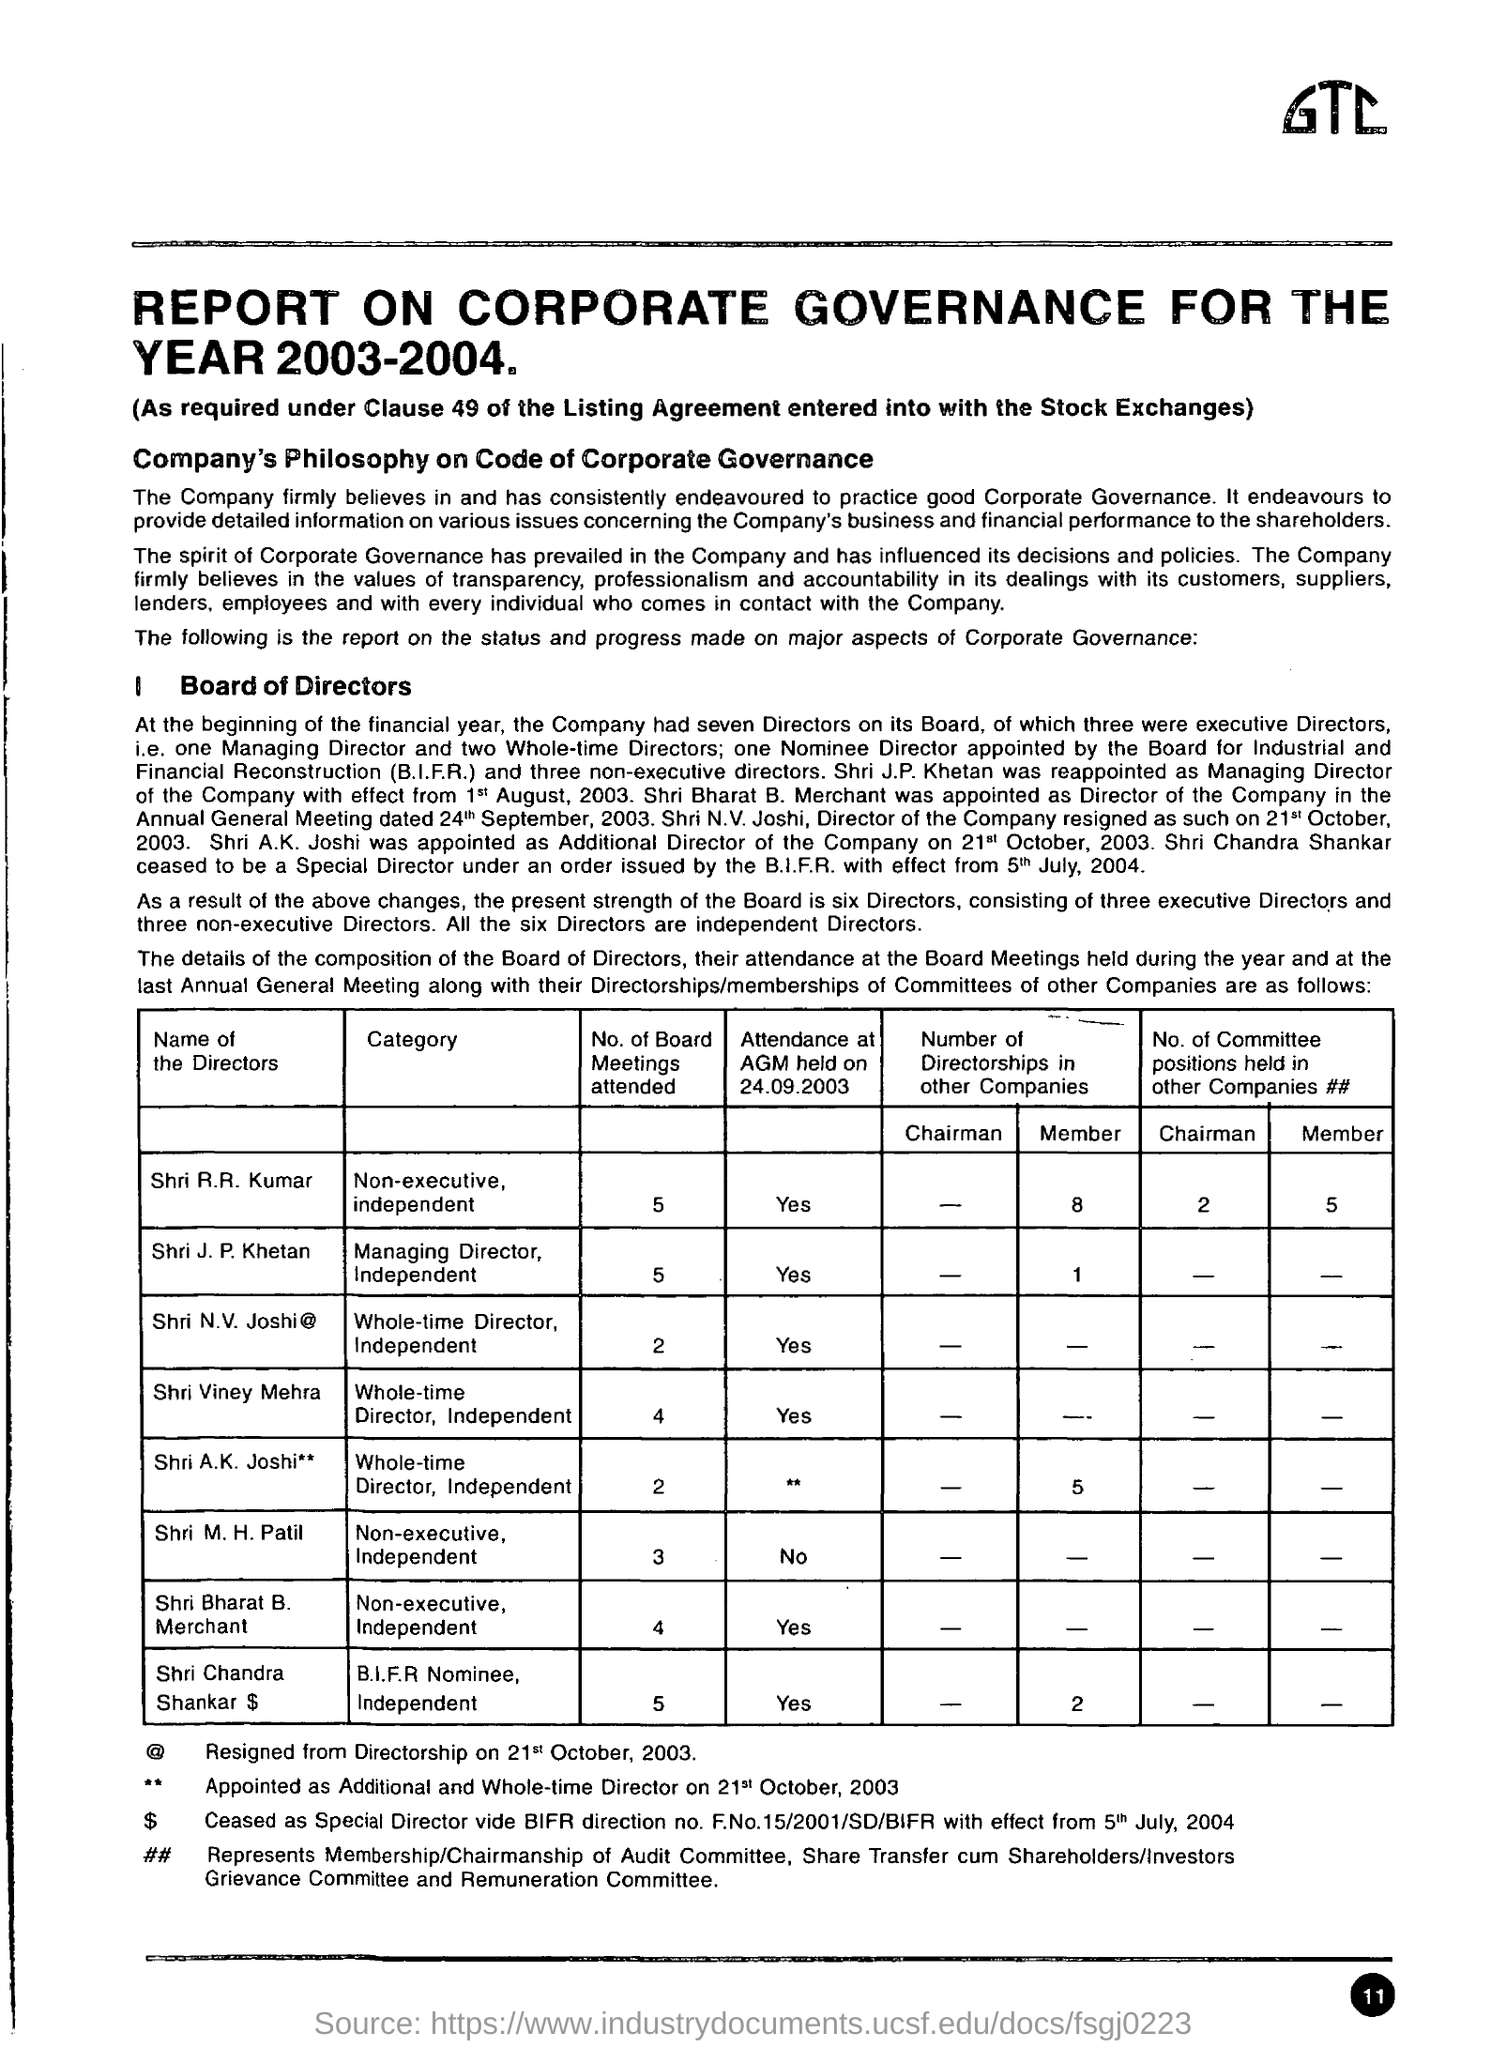At the beginning of the financial year, how many directors did the company have? According to the 'REPORT ON CORPORATE GOVERNANCE FOR THE YEAR 2003-2004', the company had seven directors at the start of that financial year. This included three executive directors, one managing director, and three non-executive directors. However, changes during the year, such as appointments and resignations, altered the board's composition to six directors. 